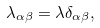<formula> <loc_0><loc_0><loc_500><loc_500>\lambda _ { \alpha \beta } = \lambda \delta _ { \alpha \beta } ,</formula> 